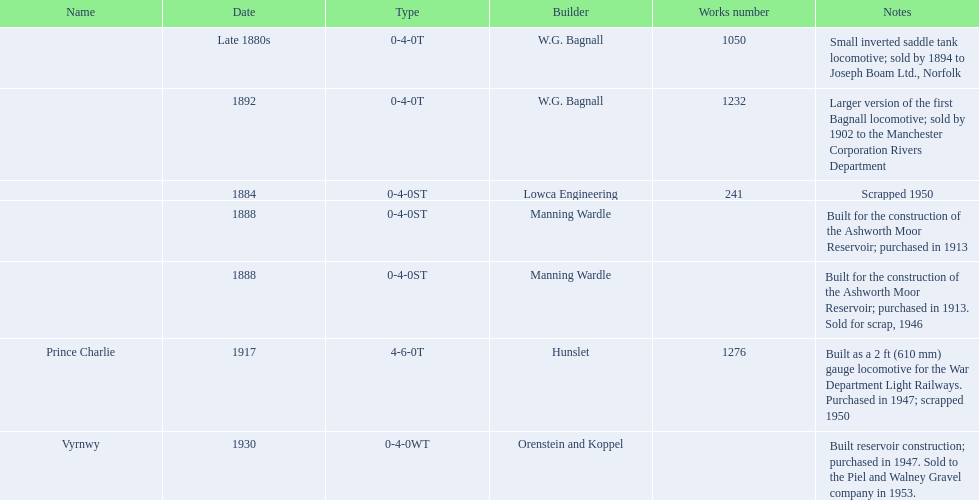Who built the larger version of the first bagnall locomotive? W.G. Bagnall. 